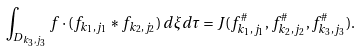Convert formula to latex. <formula><loc_0><loc_0><loc_500><loc_500>\int _ { D _ { k _ { 3 } , j _ { 3 } } } f \cdot ( f _ { k _ { 1 } , j _ { 1 } } \ast f _ { k _ { 2 } , j _ { 2 } } ) \, d \xi d \tau = J ( f ^ { \# } _ { k _ { 1 } , j _ { 1 } } , f ^ { \# } _ { k _ { 2 } , j _ { 2 } } , f ^ { \# } _ { k _ { 3 } , j _ { 3 } } ) .</formula> 